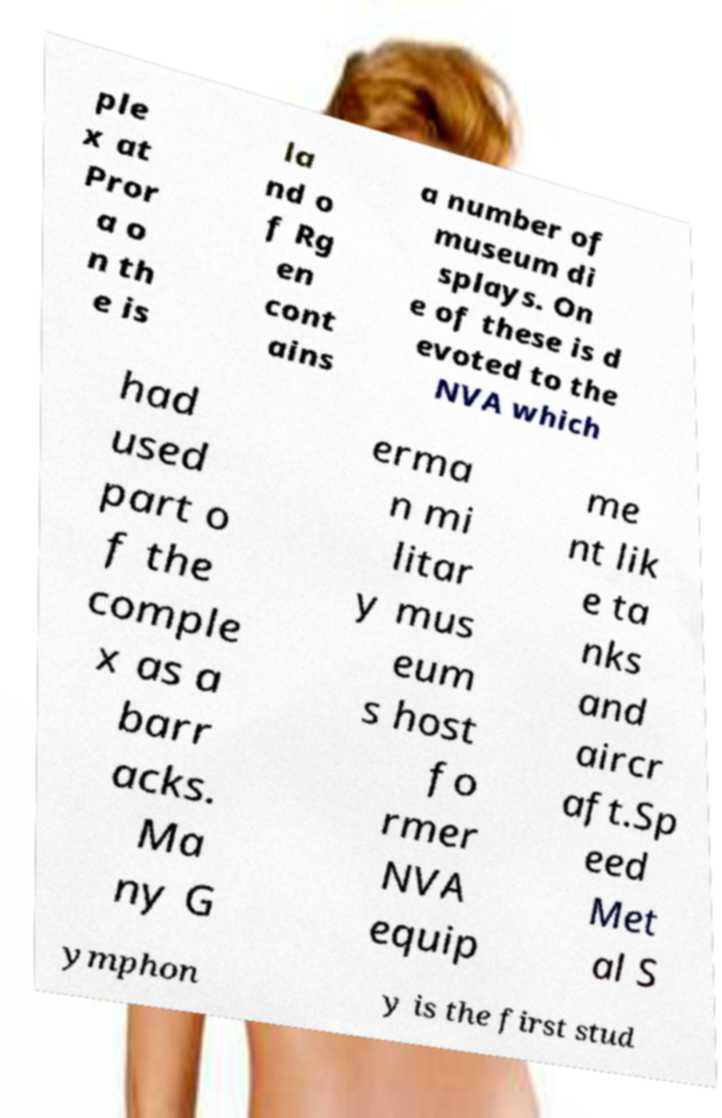I need the written content from this picture converted into text. Can you do that? ple x at Pror a o n th e is la nd o f Rg en cont ains a number of museum di splays. On e of these is d evoted to the NVA which had used part o f the comple x as a barr acks. Ma ny G erma n mi litar y mus eum s host fo rmer NVA equip me nt lik e ta nks and aircr aft.Sp eed Met al S ymphon y is the first stud 